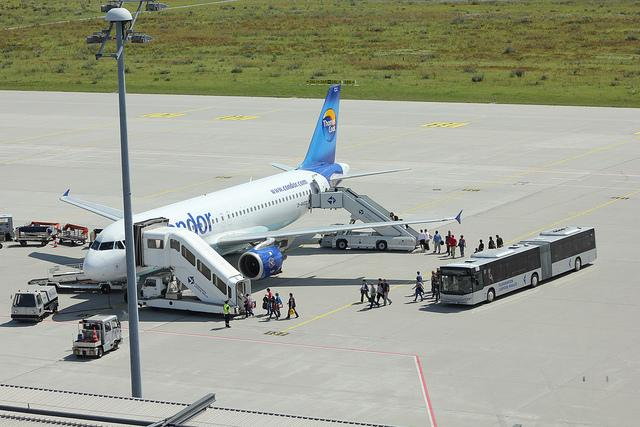What is the name of the blue piece on the end of the plane?

Choices:
A) slats
B) wing
C) spoiler
D) vertical stabilizer vertical stabilizer 